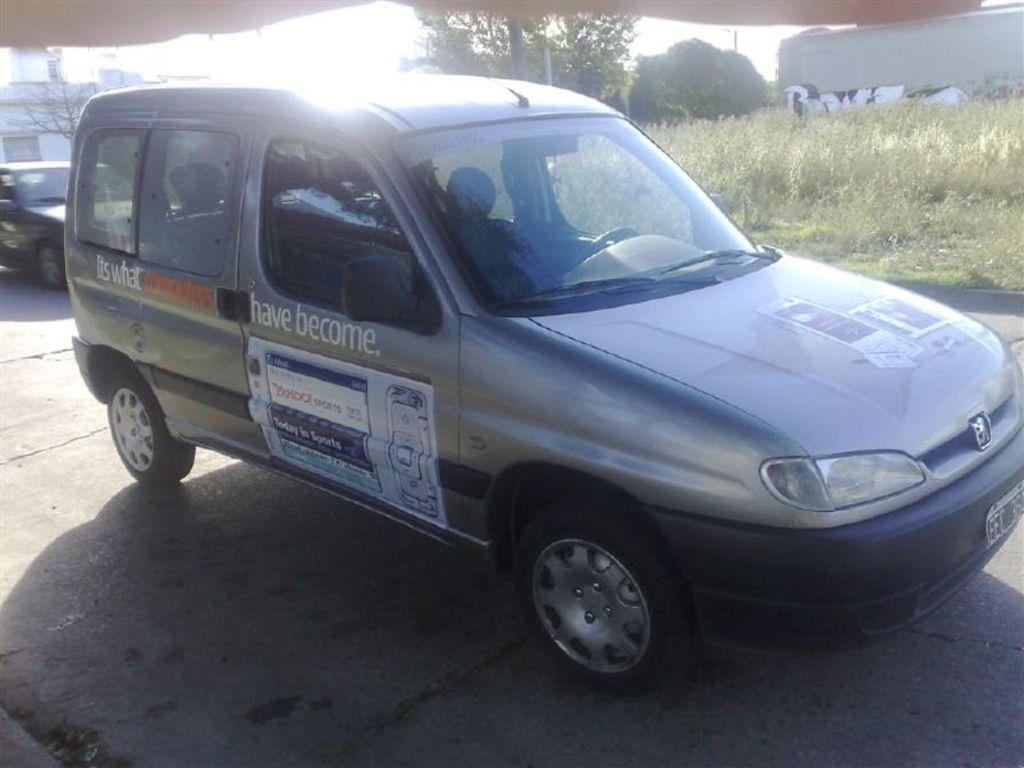Provide a one-sentence caption for the provided image. A grey van is parked in a driveway with the words have become on the side. 